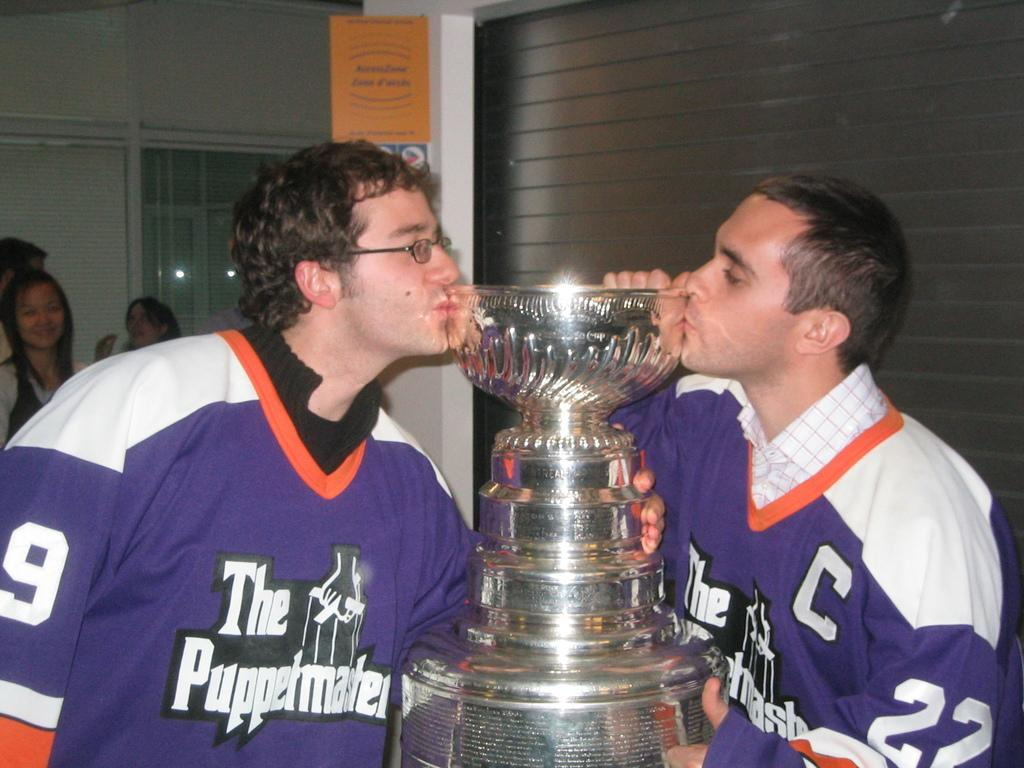<image>
Describe the image concisely. Two players in Puppetmasters uniforms give kisses to the Stanley Cup. 